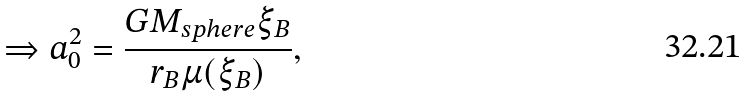<formula> <loc_0><loc_0><loc_500><loc_500>\Rightarrow a _ { 0 } ^ { 2 } = \frac { G M _ { s p h e r e } \xi _ { B } } { r _ { B } \mu ( \xi _ { B } ) } ,</formula> 